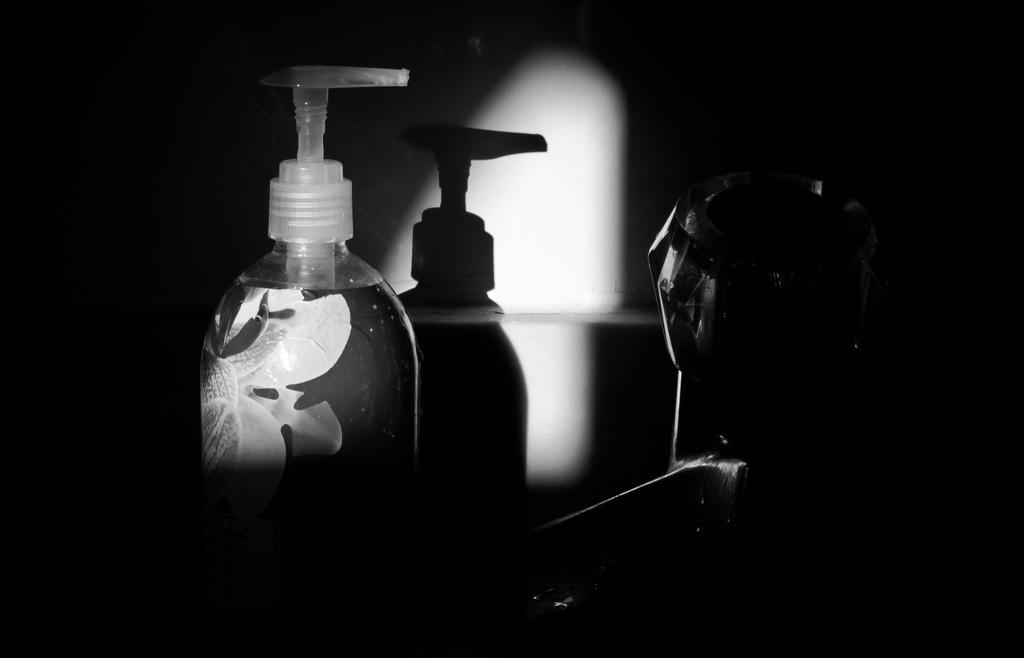Describe this image in one or two sentences. This is a dark image. Here we can see a bottle and an object. On the wall we can see the shadow of a bottle. 